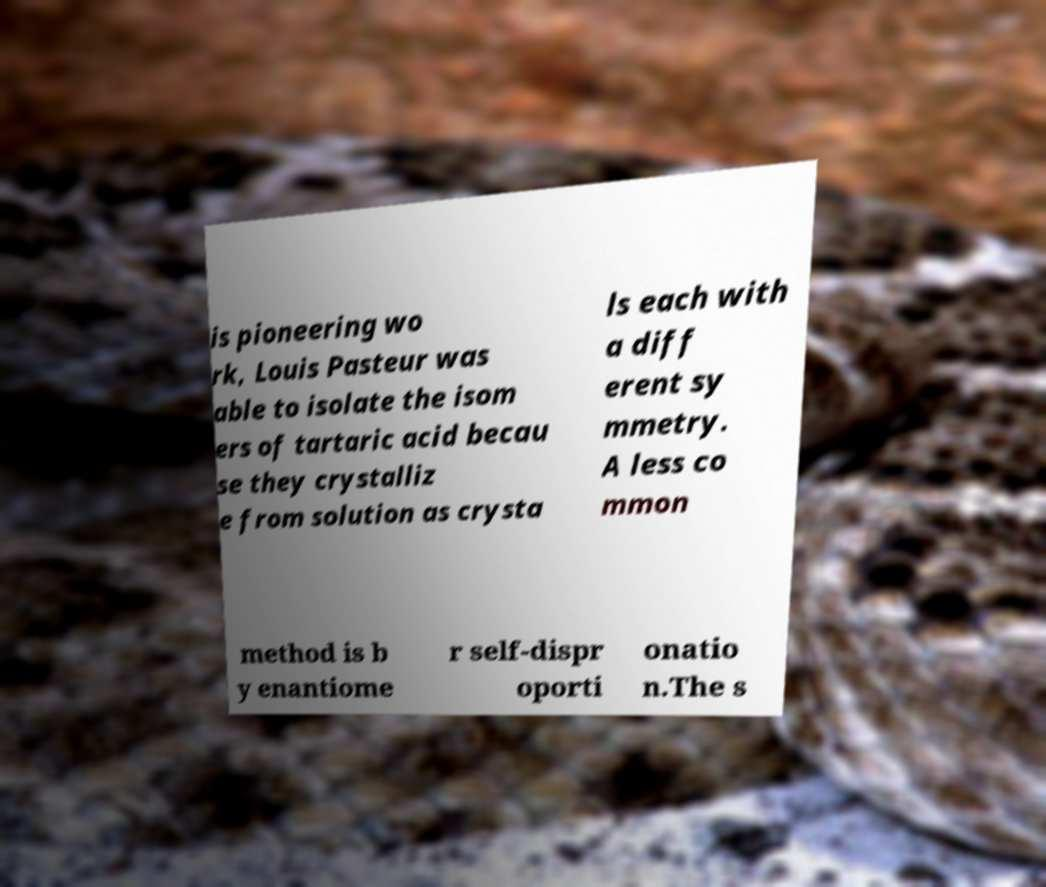Can you read and provide the text displayed in the image?This photo seems to have some interesting text. Can you extract and type it out for me? is pioneering wo rk, Louis Pasteur was able to isolate the isom ers of tartaric acid becau se they crystalliz e from solution as crysta ls each with a diff erent sy mmetry. A less co mmon method is b y enantiome r self-dispr oporti onatio n.The s 